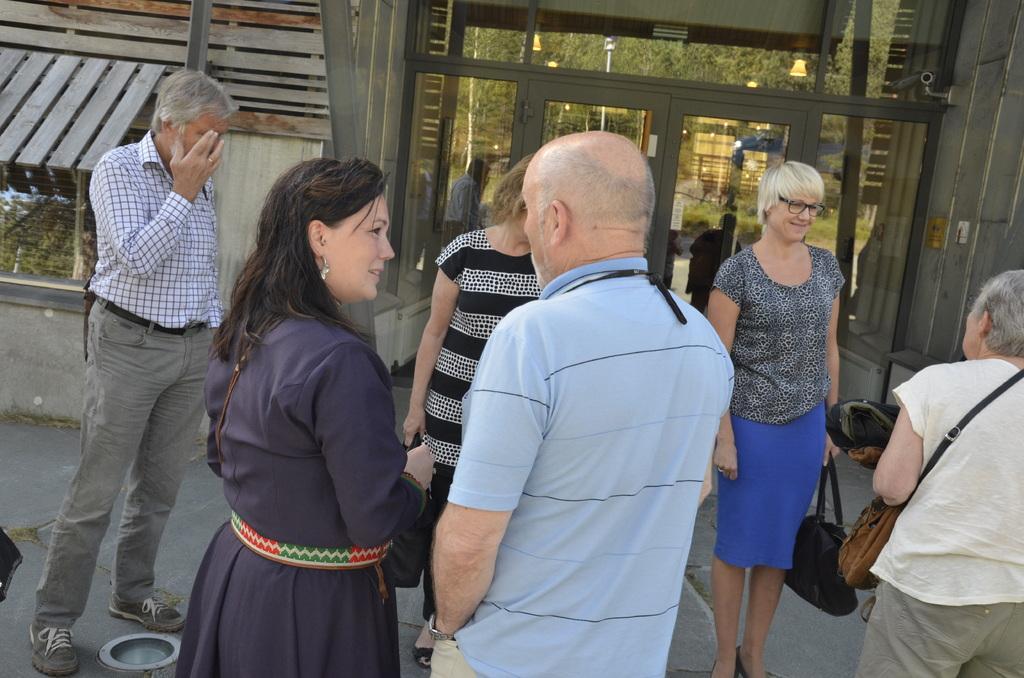In one or two sentences, can you explain what this image depicts? There are persons in different color dresses on the floor. In the background, there is a building having glass doors. 